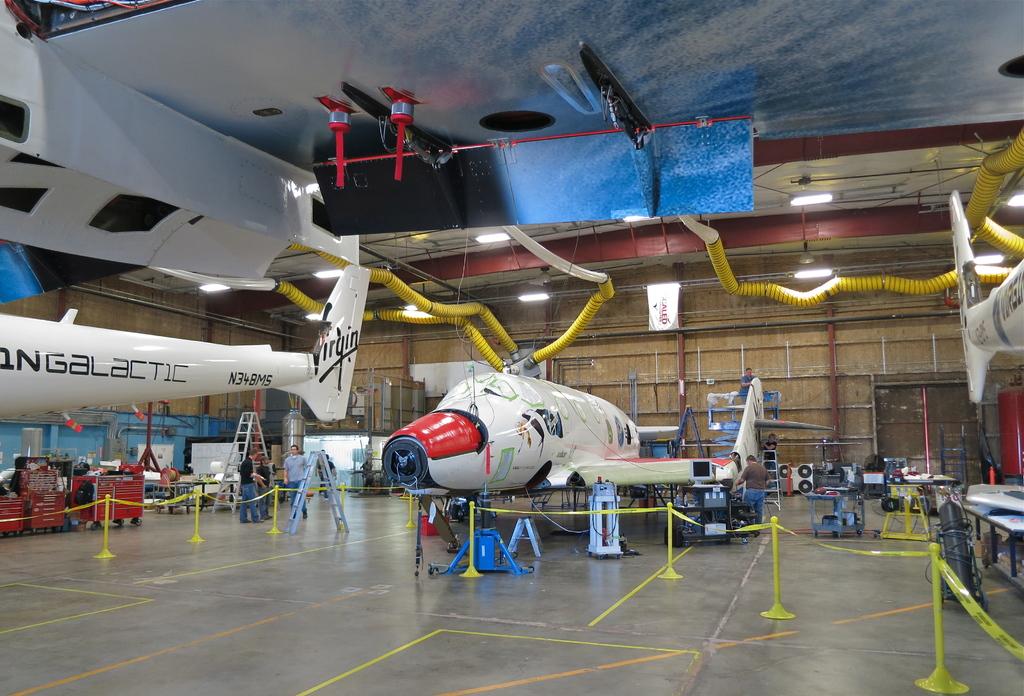Which airline is this?
Keep it short and to the point. Virgin. This is natural palce?
Give a very brief answer. Answering does not require reading text in the image. 